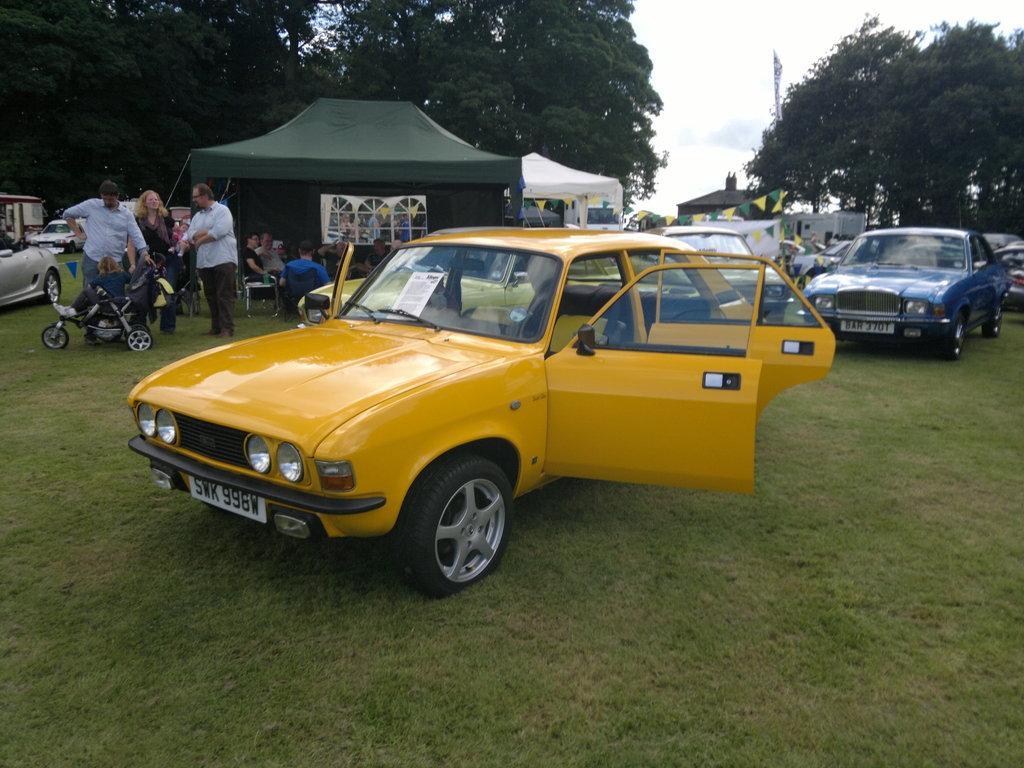Please provide a concise description of this image. In this image we can see a group of cars placed on the ground. We can also see some grass, a baby in a carrier and some people standing. On the backside we can see a group of people sitting on the chairs under the tent, a building, some paper flags tied to a thread, a group of trees, a house and the sky which looks cloudy. 